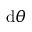Convert formula to latex. <formula><loc_0><loc_0><loc_500><loc_500>d \theta</formula> 